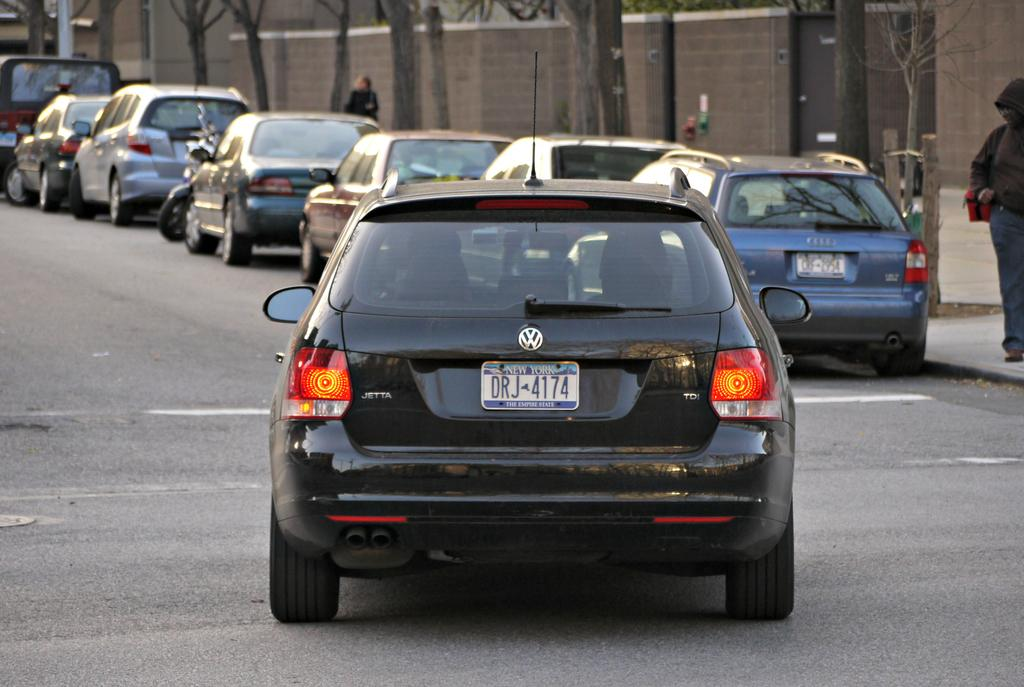What types of objects are in the image? There are vehicles and persons in the image. What can be seen in the background of the image? There are trees in the image. What architectural feature is present in the image? There is a wall in the image. How many sheep are present in the image? There are no sheep present in the image. What type of yoke is being used by the persons in the image? There is no yoke present in the image. 